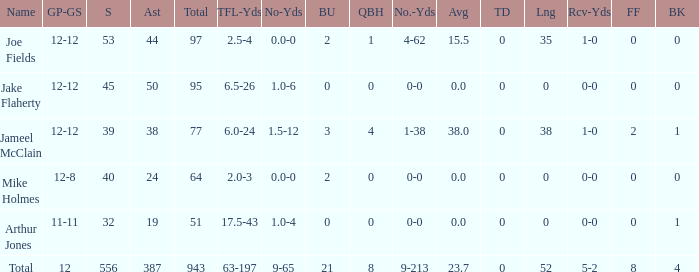What is the largest number of tds scored for a player? 0.0. 